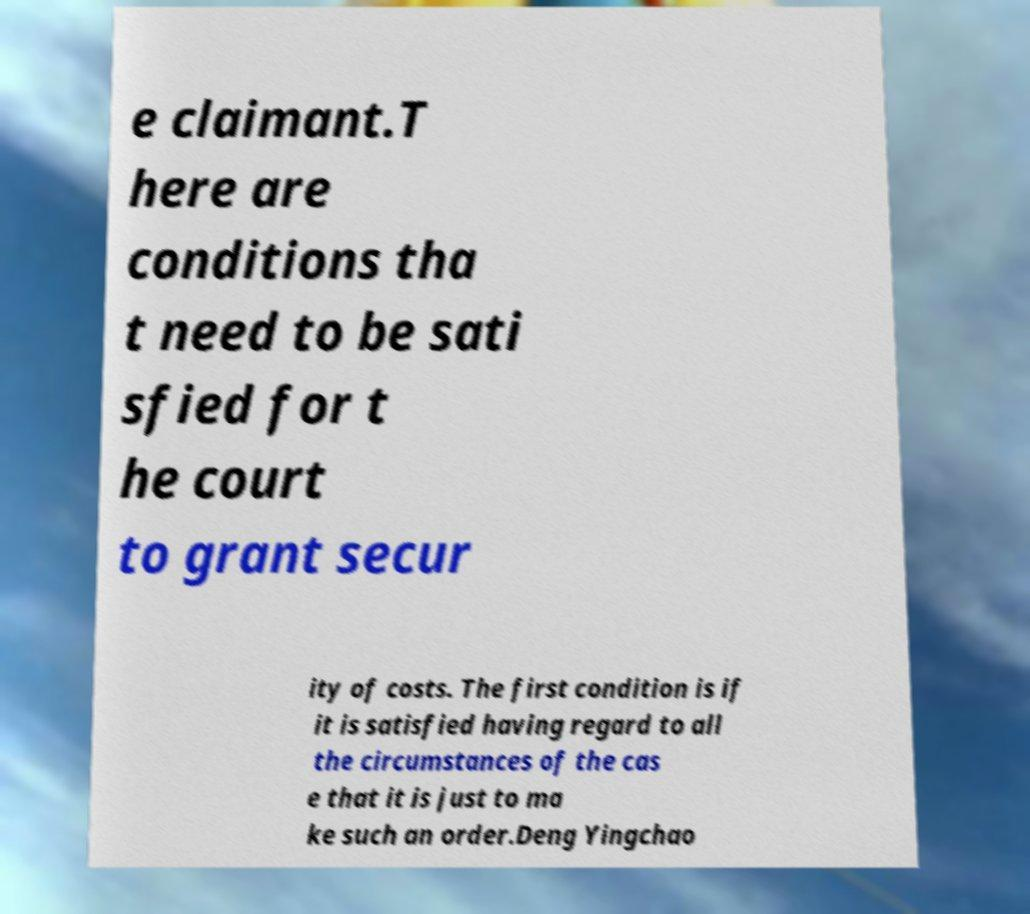Can you accurately transcribe the text from the provided image for me? e claimant.T here are conditions tha t need to be sati sfied for t he court to grant secur ity of costs. The first condition is if it is satisfied having regard to all the circumstances of the cas e that it is just to ma ke such an order.Deng Yingchao 